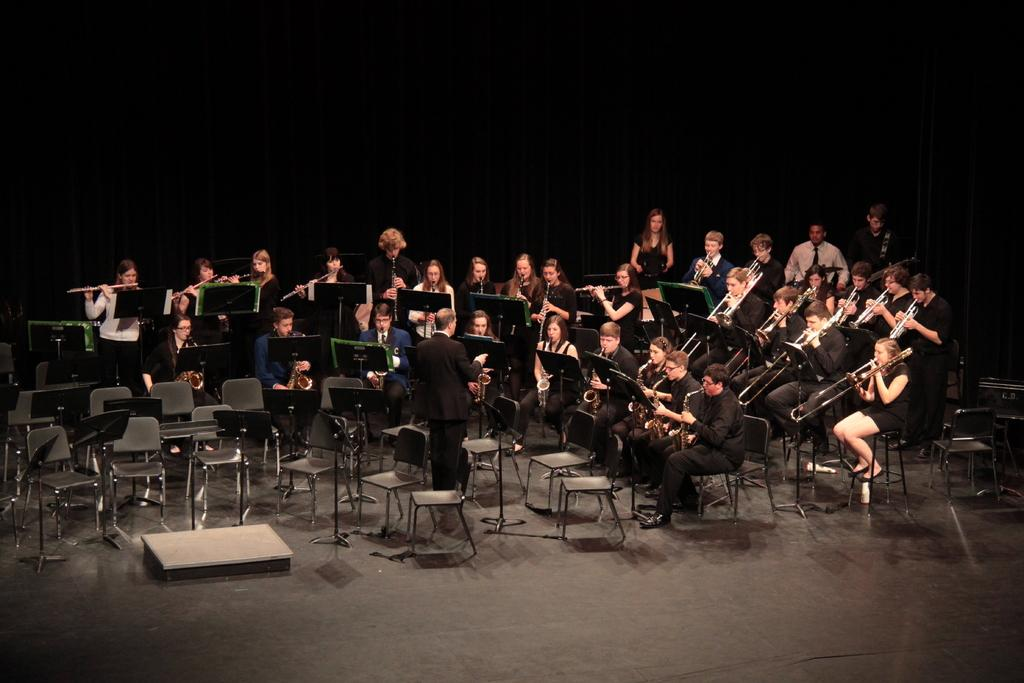What are the people in the image doing? The people in the image are playing musical instruments. Are there any people sitting down in the image? Yes, there are people sitting on chairs in the image. What is the position of the person who is not sitting down? There is a person standing on the floor in the image. How would you describe the lighting in the image? The background of the image is dark. What type of store can be seen in the background of the image? There is no store visible in the image; the background is dark. Can you tell me what order the people are following while playing their instruments? There is no indication of a specific order in the image; the people are simply playing their instruments. Is there a rod visible in the image? There is no rod present in the image. 